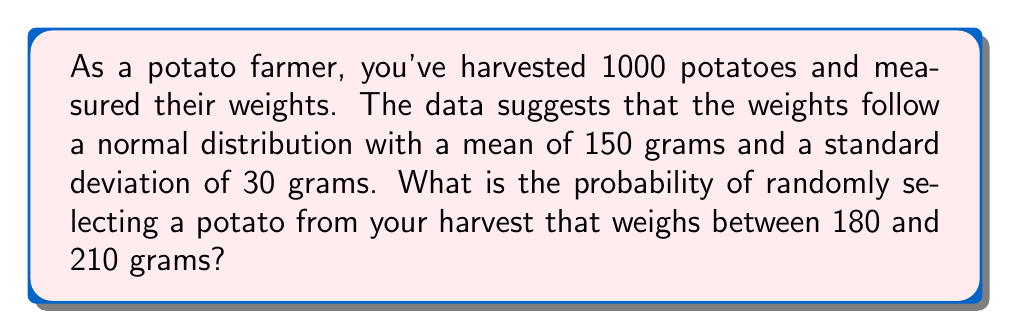Could you help me with this problem? Let's approach this step-by-step:

1) We're dealing with a normal distribution where:
   $\mu = 150$ grams (mean)
   $\sigma = 30$ grams (standard deviation)

2) We need to find P(180 < X < 210), where X is the weight of a randomly selected potato.

3) To use the standard normal distribution, we need to standardize these values:
   For 180 grams: $z_1 = \frac{180 - 150}{30} = 1$
   For 210 grams: $z_2 = \frac{210 - 150}{30} = 2$

4) Now we need to find P(1 < Z < 2) where Z is the standard normal variable.

5) Using the standard normal distribution table:
   P(Z < 2) = 0.9772
   P(Z < 1) = 0.8413

6) Therefore:
   P(1 < Z < 2) = P(Z < 2) - P(Z < 1)
                = 0.9772 - 0.8413
                = 0.1359

7) Convert to a percentage: 0.1359 * 100 = 13.59%

Thus, the probability of randomly selecting a potato weighing between 180 and 210 grams is approximately 13.59%.
Answer: 13.59% 